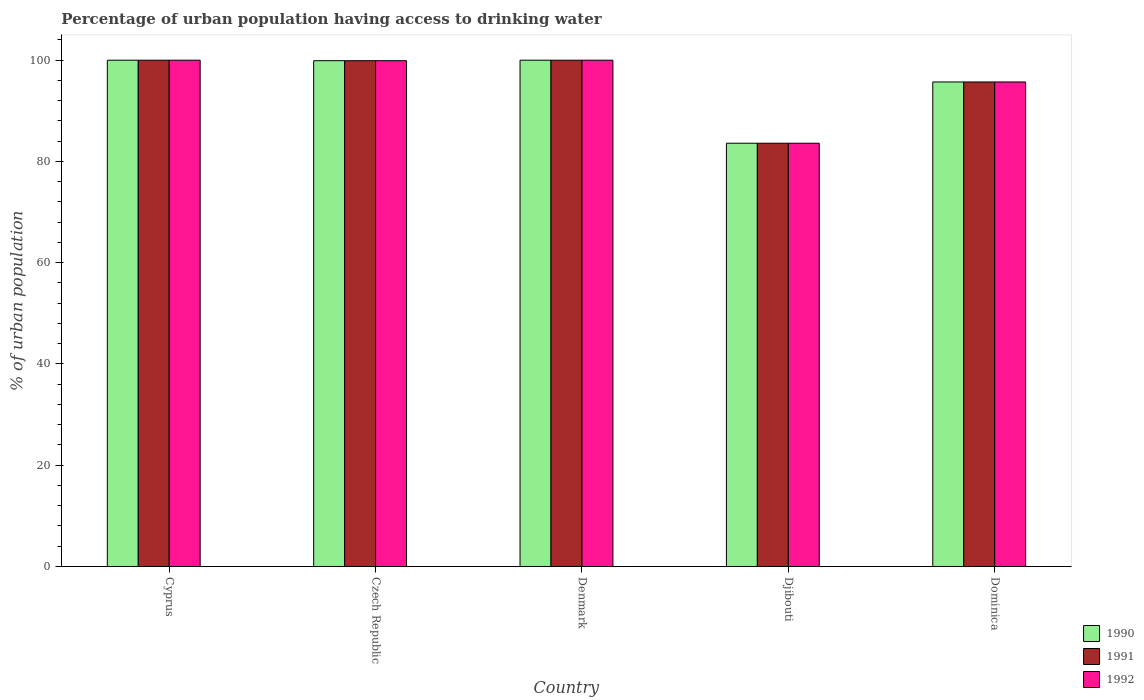Are the number of bars on each tick of the X-axis equal?
Ensure brevity in your answer.  Yes. How many bars are there on the 3rd tick from the left?
Offer a terse response. 3. What is the label of the 2nd group of bars from the left?
Provide a short and direct response. Czech Republic. What is the percentage of urban population having access to drinking water in 1990 in Dominica?
Give a very brief answer. 95.7. Across all countries, what is the minimum percentage of urban population having access to drinking water in 1992?
Keep it short and to the point. 83.6. In which country was the percentage of urban population having access to drinking water in 1992 maximum?
Provide a succinct answer. Cyprus. In which country was the percentage of urban population having access to drinking water in 1991 minimum?
Offer a very short reply. Djibouti. What is the total percentage of urban population having access to drinking water in 1991 in the graph?
Provide a succinct answer. 479.2. What is the difference between the percentage of urban population having access to drinking water in 1991 in Djibouti and that in Dominica?
Provide a short and direct response. -12.1. What is the difference between the percentage of urban population having access to drinking water in 1990 in Cyprus and the percentage of urban population having access to drinking water in 1992 in Dominica?
Make the answer very short. 4.3. What is the average percentage of urban population having access to drinking water in 1992 per country?
Keep it short and to the point. 95.84. What is the difference between the percentage of urban population having access to drinking water of/in 1990 and percentage of urban population having access to drinking water of/in 1991 in Denmark?
Provide a succinct answer. 0. What is the ratio of the percentage of urban population having access to drinking water in 1990 in Djibouti to that in Dominica?
Your answer should be very brief. 0.87. What is the difference between the highest and the second highest percentage of urban population having access to drinking water in 1990?
Make the answer very short. -0.1. What is the difference between the highest and the lowest percentage of urban population having access to drinking water in 1992?
Give a very brief answer. 16.4. How many bars are there?
Your answer should be compact. 15. How many countries are there in the graph?
Provide a short and direct response. 5. Does the graph contain any zero values?
Offer a very short reply. No. Where does the legend appear in the graph?
Make the answer very short. Bottom right. How many legend labels are there?
Give a very brief answer. 3. How are the legend labels stacked?
Provide a succinct answer. Vertical. What is the title of the graph?
Provide a succinct answer. Percentage of urban population having access to drinking water. What is the label or title of the Y-axis?
Your answer should be compact. % of urban population. What is the % of urban population in 1990 in Cyprus?
Your answer should be compact. 100. What is the % of urban population in 1990 in Czech Republic?
Ensure brevity in your answer.  99.9. What is the % of urban population of 1991 in Czech Republic?
Provide a succinct answer. 99.9. What is the % of urban population in 1992 in Czech Republic?
Provide a short and direct response. 99.9. What is the % of urban population of 1991 in Denmark?
Offer a very short reply. 100. What is the % of urban population in 1992 in Denmark?
Your response must be concise. 100. What is the % of urban population in 1990 in Djibouti?
Your answer should be very brief. 83.6. What is the % of urban population of 1991 in Djibouti?
Your answer should be compact. 83.6. What is the % of urban population of 1992 in Djibouti?
Ensure brevity in your answer.  83.6. What is the % of urban population of 1990 in Dominica?
Your answer should be compact. 95.7. What is the % of urban population of 1991 in Dominica?
Provide a short and direct response. 95.7. What is the % of urban population in 1992 in Dominica?
Provide a short and direct response. 95.7. Across all countries, what is the maximum % of urban population in 1990?
Your response must be concise. 100. Across all countries, what is the maximum % of urban population in 1991?
Your answer should be very brief. 100. Across all countries, what is the minimum % of urban population in 1990?
Your response must be concise. 83.6. Across all countries, what is the minimum % of urban population in 1991?
Your answer should be very brief. 83.6. Across all countries, what is the minimum % of urban population in 1992?
Ensure brevity in your answer.  83.6. What is the total % of urban population in 1990 in the graph?
Your response must be concise. 479.2. What is the total % of urban population of 1991 in the graph?
Your response must be concise. 479.2. What is the total % of urban population in 1992 in the graph?
Give a very brief answer. 479.2. What is the difference between the % of urban population in 1992 in Cyprus and that in Denmark?
Your answer should be compact. 0. What is the difference between the % of urban population of 1990 in Cyprus and that in Djibouti?
Offer a very short reply. 16.4. What is the difference between the % of urban population in 1991 in Cyprus and that in Djibouti?
Your response must be concise. 16.4. What is the difference between the % of urban population in 1992 in Cyprus and that in Djibouti?
Your answer should be compact. 16.4. What is the difference between the % of urban population of 1992 in Cyprus and that in Dominica?
Provide a succinct answer. 4.3. What is the difference between the % of urban population of 1990 in Czech Republic and that in Denmark?
Make the answer very short. -0.1. What is the difference between the % of urban population in 1991 in Czech Republic and that in Denmark?
Your answer should be very brief. -0.1. What is the difference between the % of urban population of 1990 in Czech Republic and that in Djibouti?
Offer a very short reply. 16.3. What is the difference between the % of urban population of 1992 in Czech Republic and that in Dominica?
Keep it short and to the point. 4.2. What is the difference between the % of urban population in 1991 in Denmark and that in Djibouti?
Make the answer very short. 16.4. What is the difference between the % of urban population of 1992 in Denmark and that in Djibouti?
Your response must be concise. 16.4. What is the difference between the % of urban population of 1992 in Denmark and that in Dominica?
Offer a terse response. 4.3. What is the difference between the % of urban population of 1990 in Djibouti and that in Dominica?
Your answer should be compact. -12.1. What is the difference between the % of urban population in 1990 in Cyprus and the % of urban population in 1991 in Czech Republic?
Your answer should be very brief. 0.1. What is the difference between the % of urban population of 1990 in Cyprus and the % of urban population of 1992 in Denmark?
Ensure brevity in your answer.  0. What is the difference between the % of urban population in 1991 in Cyprus and the % of urban population in 1992 in Denmark?
Make the answer very short. 0. What is the difference between the % of urban population of 1990 in Cyprus and the % of urban population of 1991 in Dominica?
Your response must be concise. 4.3. What is the difference between the % of urban population in 1990 in Czech Republic and the % of urban population in 1991 in Djibouti?
Your answer should be very brief. 16.3. What is the difference between the % of urban population in 1990 in Czech Republic and the % of urban population in 1992 in Djibouti?
Your answer should be compact. 16.3. What is the difference between the % of urban population in 1991 in Czech Republic and the % of urban population in 1992 in Djibouti?
Offer a terse response. 16.3. What is the difference between the % of urban population of 1991 in Czech Republic and the % of urban population of 1992 in Dominica?
Give a very brief answer. 4.2. What is the difference between the % of urban population in 1990 in Denmark and the % of urban population in 1992 in Djibouti?
Your response must be concise. 16.4. What is the difference between the % of urban population of 1990 in Denmark and the % of urban population of 1992 in Dominica?
Your answer should be compact. 4.3. What is the difference between the % of urban population in 1990 in Djibouti and the % of urban population in 1992 in Dominica?
Your answer should be compact. -12.1. What is the difference between the % of urban population of 1991 in Djibouti and the % of urban population of 1992 in Dominica?
Offer a terse response. -12.1. What is the average % of urban population of 1990 per country?
Give a very brief answer. 95.84. What is the average % of urban population in 1991 per country?
Provide a short and direct response. 95.84. What is the average % of urban population in 1992 per country?
Your response must be concise. 95.84. What is the difference between the % of urban population of 1990 and % of urban population of 1991 in Cyprus?
Ensure brevity in your answer.  0. What is the difference between the % of urban population of 1990 and % of urban population of 1992 in Cyprus?
Offer a very short reply. 0. What is the difference between the % of urban population of 1990 and % of urban population of 1991 in Czech Republic?
Offer a terse response. 0. What is the difference between the % of urban population in 1991 and % of urban population in 1992 in Czech Republic?
Offer a very short reply. 0. What is the difference between the % of urban population in 1991 and % of urban population in 1992 in Denmark?
Provide a succinct answer. 0. What is the difference between the % of urban population in 1990 and % of urban population in 1991 in Djibouti?
Give a very brief answer. 0. What is the difference between the % of urban population in 1991 and % of urban population in 1992 in Dominica?
Provide a succinct answer. 0. What is the ratio of the % of urban population of 1992 in Cyprus to that in Denmark?
Your answer should be compact. 1. What is the ratio of the % of urban population in 1990 in Cyprus to that in Djibouti?
Keep it short and to the point. 1.2. What is the ratio of the % of urban population of 1991 in Cyprus to that in Djibouti?
Your response must be concise. 1.2. What is the ratio of the % of urban population in 1992 in Cyprus to that in Djibouti?
Offer a terse response. 1.2. What is the ratio of the % of urban population of 1990 in Cyprus to that in Dominica?
Your response must be concise. 1.04. What is the ratio of the % of urban population in 1991 in Cyprus to that in Dominica?
Provide a short and direct response. 1.04. What is the ratio of the % of urban population of 1992 in Cyprus to that in Dominica?
Offer a very short reply. 1.04. What is the ratio of the % of urban population in 1991 in Czech Republic to that in Denmark?
Offer a very short reply. 1. What is the ratio of the % of urban population in 1990 in Czech Republic to that in Djibouti?
Your answer should be very brief. 1.2. What is the ratio of the % of urban population in 1991 in Czech Republic to that in Djibouti?
Offer a terse response. 1.2. What is the ratio of the % of urban population in 1992 in Czech Republic to that in Djibouti?
Your response must be concise. 1.2. What is the ratio of the % of urban population of 1990 in Czech Republic to that in Dominica?
Make the answer very short. 1.04. What is the ratio of the % of urban population in 1991 in Czech Republic to that in Dominica?
Provide a short and direct response. 1.04. What is the ratio of the % of urban population of 1992 in Czech Republic to that in Dominica?
Your response must be concise. 1.04. What is the ratio of the % of urban population in 1990 in Denmark to that in Djibouti?
Ensure brevity in your answer.  1.2. What is the ratio of the % of urban population of 1991 in Denmark to that in Djibouti?
Your response must be concise. 1.2. What is the ratio of the % of urban population in 1992 in Denmark to that in Djibouti?
Provide a succinct answer. 1.2. What is the ratio of the % of urban population of 1990 in Denmark to that in Dominica?
Provide a succinct answer. 1.04. What is the ratio of the % of urban population of 1991 in Denmark to that in Dominica?
Provide a succinct answer. 1.04. What is the ratio of the % of urban population in 1992 in Denmark to that in Dominica?
Provide a succinct answer. 1.04. What is the ratio of the % of urban population in 1990 in Djibouti to that in Dominica?
Give a very brief answer. 0.87. What is the ratio of the % of urban population in 1991 in Djibouti to that in Dominica?
Ensure brevity in your answer.  0.87. What is the ratio of the % of urban population in 1992 in Djibouti to that in Dominica?
Your response must be concise. 0.87. What is the difference between the highest and the second highest % of urban population in 1991?
Offer a terse response. 0. What is the difference between the highest and the second highest % of urban population in 1992?
Offer a very short reply. 0. What is the difference between the highest and the lowest % of urban population of 1991?
Give a very brief answer. 16.4. What is the difference between the highest and the lowest % of urban population in 1992?
Offer a terse response. 16.4. 